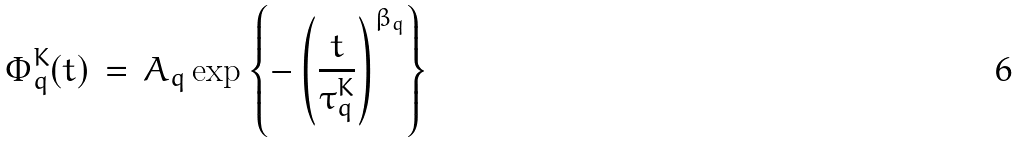Convert formula to latex. <formula><loc_0><loc_0><loc_500><loc_500>\Phi _ { q } ^ { K } ( t ) \, = \, A _ { q } \exp \left \{ - \left ( \frac { t } { \tau _ { q } ^ { K } } \right ) ^ { \beta _ { q } } \right \}</formula> 